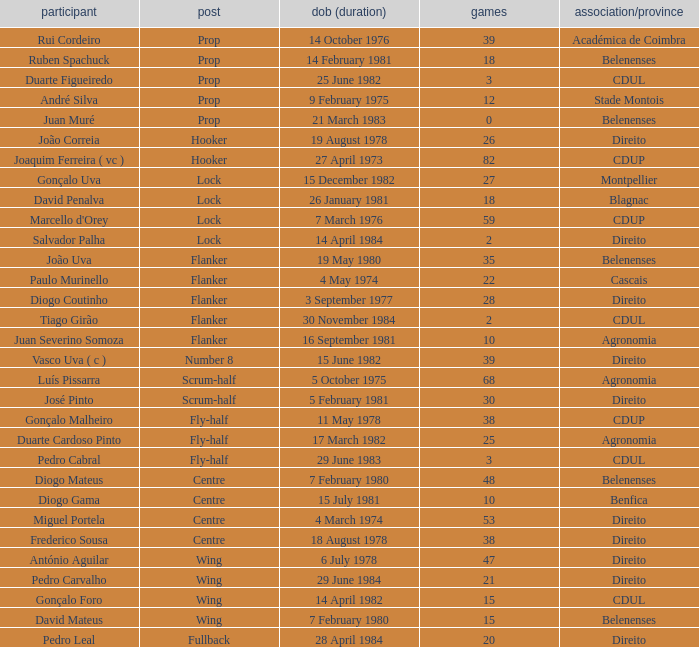Which Club/province has a Player of david penalva? Blagnac. 